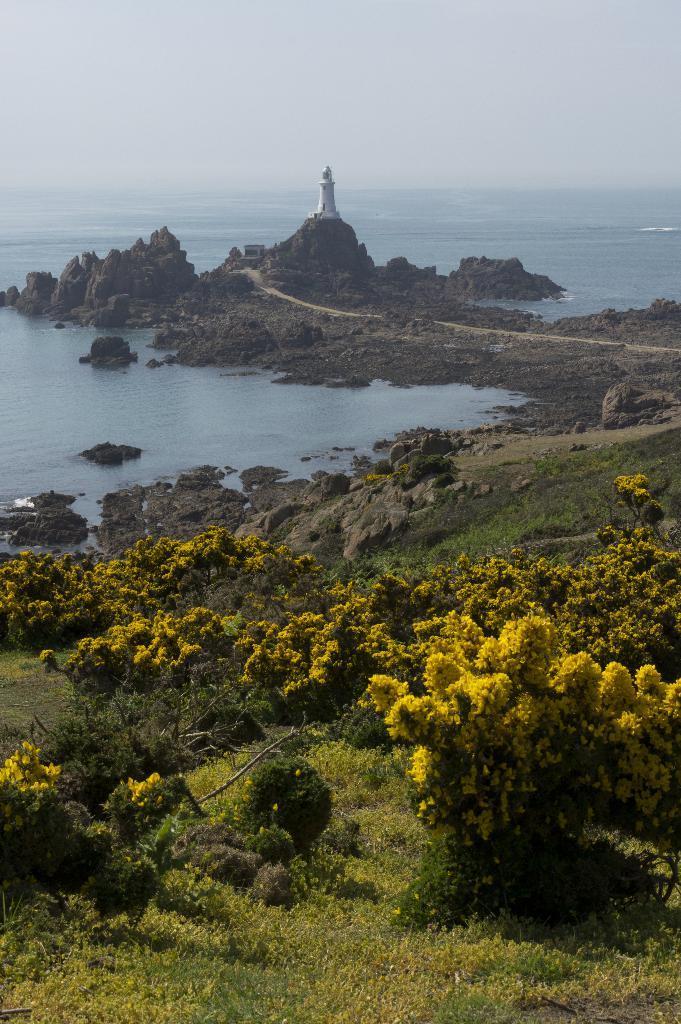In one or two sentences, can you explain what this image depicts? This image consists of plants. At the bottom, there is green grass on the ground. In the front, it looks like an ocean. And we can see a small house. At the top, there is sky. 